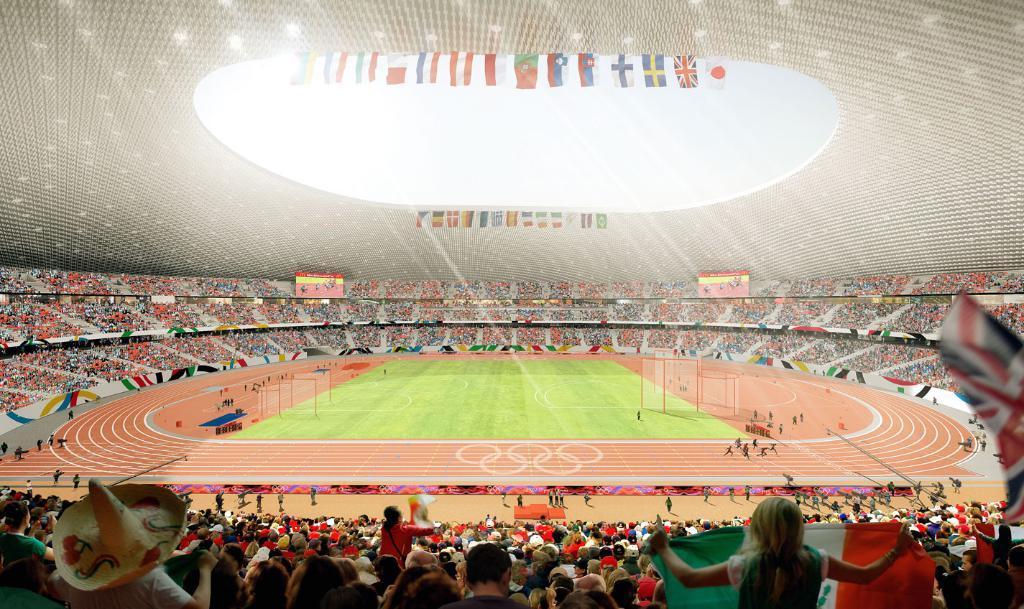Can you describe this image briefly? As we can see in the image there is a stadium. In stadium there are group of people sitting here and there. Few of them are playing in ground. 